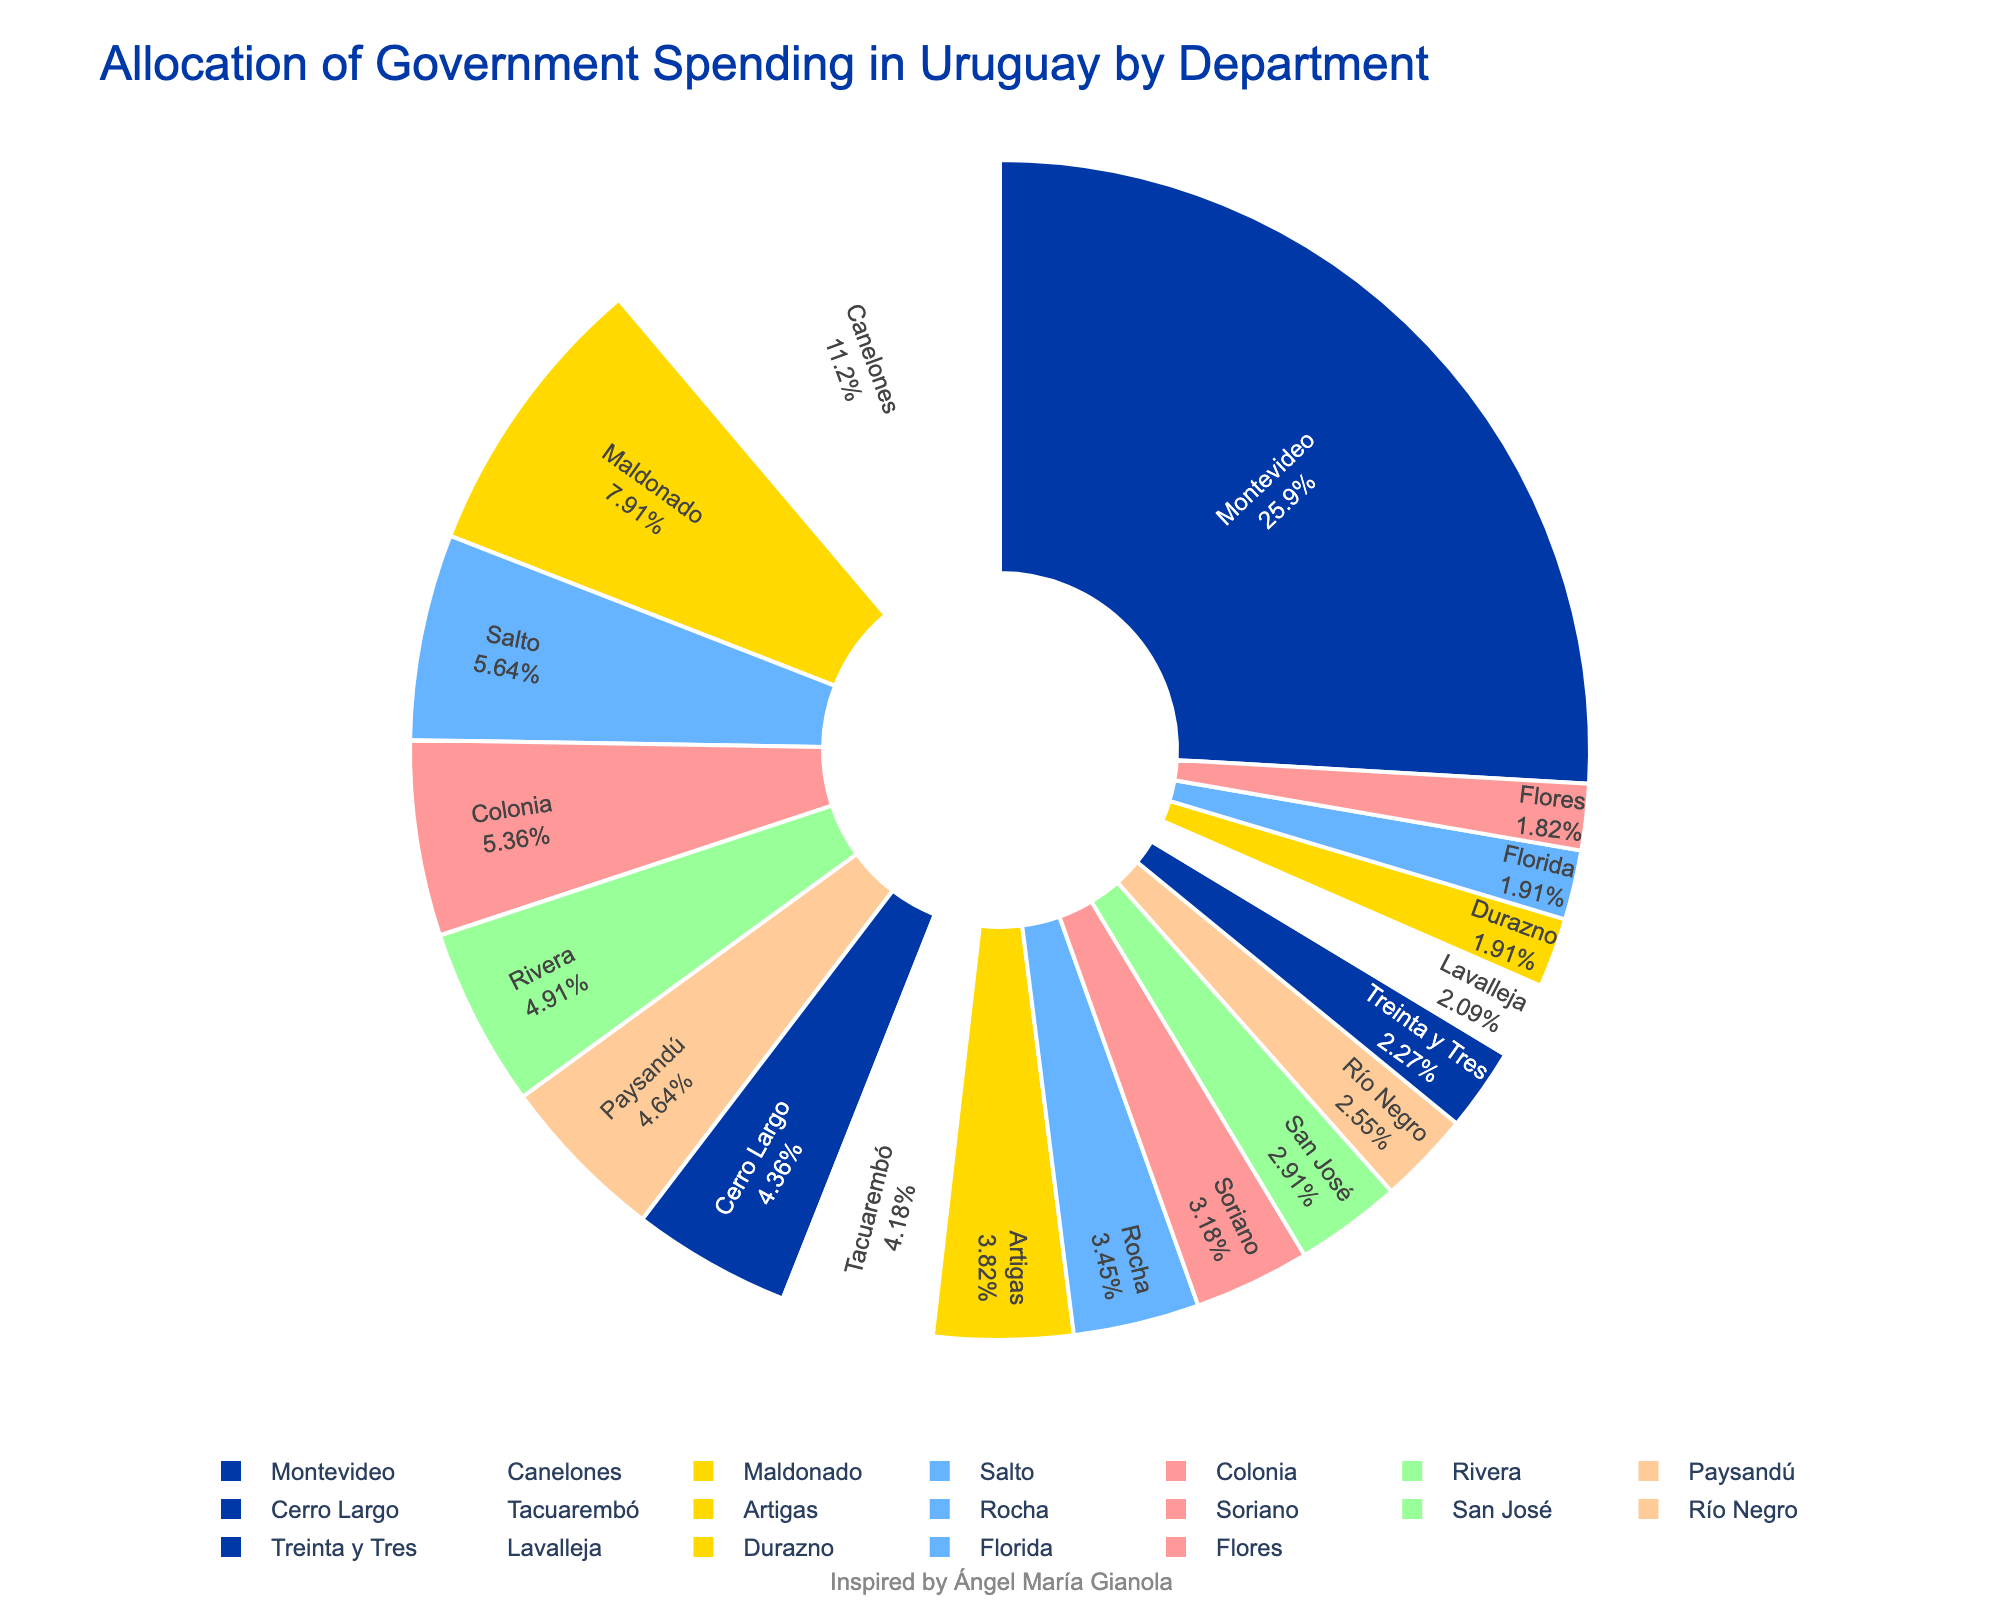Which department receives the highest percentage of government spending? Montevideo has the highest percentage slice in the pie chart.
Answer: Montevideo What is the combined percentage of spending for Montevideo and Canelones? Montevideo has 28.5% and Canelones has 12.3%. Adding these together, 28.5 + 12.3 = 40.8%.
Answer: 40.8% Which departments receive less than 5% of the government spending? From the chart, departments with less than 5% are Artigas, Rocha, Soriano, San José, Río Negro, Treinta y Tres, Lavalleja, Durazno, Flores, and Florida.
Answer: Artigas, Rocha, Soriano, San José, Río Negro, Treinta y Tres, Lavalleja, Durazno, Flores, Florida Which department receives the least percentage of government spending? The smallest slice in the pie chart corresponds to Flores at 2.0%.
Answer: Flores How much greater is the percentage of spending in Montevideo compared to Salto? Montevideo is 28.5% and Salto is 6.2%. Subtracting these, 28.5 - 6.2 = 22.3%.
Answer: 22.3% Which three departments have the largest government spending percentages, and what is their combined total? The largest slices are Montevideo (28.5%), Canelones (12.3%), and Maldonado (8.7%). Adding these together, 28.5 + 12.3 + 8.7 = 49.5%.
Answer: Montevideo, Canelones, Maldonado; 49.5% What is the average percentage of spending across all departments? Sum of all percentages is 100%, divided by 19 departments. So, 100 / 19 ≈ 5.26%.
Answer: 5.26% Which department has a percentage closest to 4%? Artigas has a percentage of 4.2%, which is the closest to 4%.
Answer: Artigas How does the percentage of spending in Durazno compare to that in Rocha? Durazno is 2.1% and Rocha is 3.8%. Rocha has a higher percentage.
Answer: Rocha has a higher percentage What is the total percentage for the departments with more than 10% of the spending? Only Montevideo (28.5%) and Canelones (12.3%) have more than 10%. Adding these, 28.5 + 12.3 = 40.8%.
Answer: 40.8% 